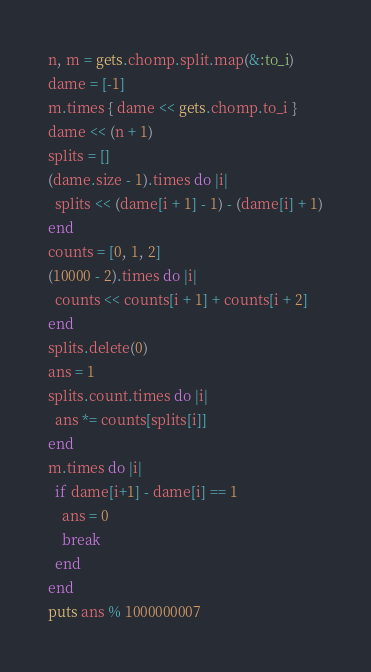Convert code to text. <code><loc_0><loc_0><loc_500><loc_500><_Ruby_>n, m = gets.chomp.split.map(&:to_i)
dame = [-1]
m.times { dame << gets.chomp.to_i }
dame << (n + 1)
splits = []
(dame.size - 1).times do |i|
  splits << (dame[i + 1] - 1) - (dame[i] + 1)
end
counts = [0, 1, 2]
(10000 - 2).times do |i|
  counts << counts[i + 1] + counts[i + 2]
end
splits.delete(0)
ans = 1
splits.count.times do |i|
  ans *= counts[splits[i]]
end
m.times do |i|
  if dame[i+1] - dame[i] == 1
    ans = 0
    break
  end
end
puts ans % 1000000007</code> 